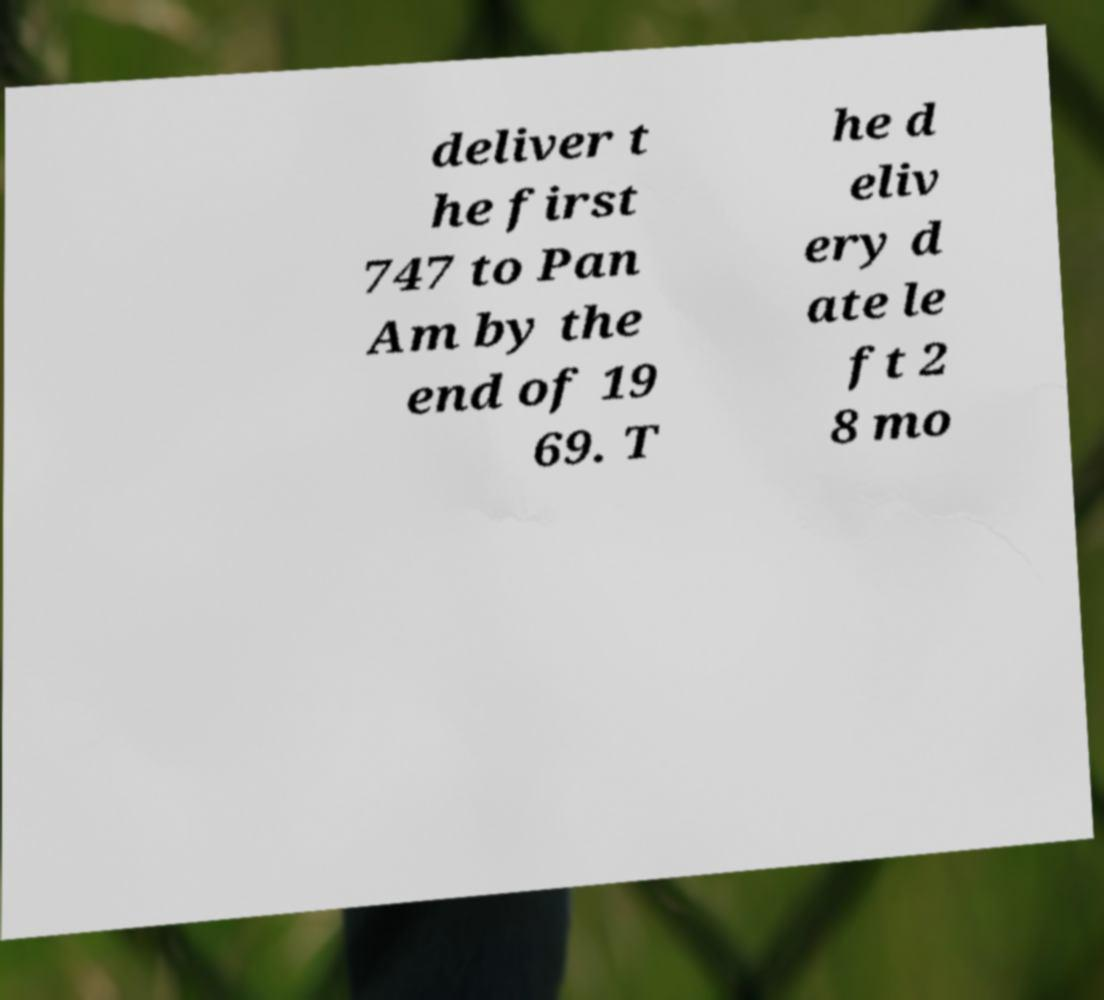Could you extract and type out the text from this image? deliver t he first 747 to Pan Am by the end of 19 69. T he d eliv ery d ate le ft 2 8 mo 